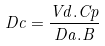Convert formula to latex. <formula><loc_0><loc_0><loc_500><loc_500>D c = \frac { V d . C p } { D a . B }</formula> 